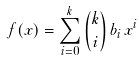Convert formula to latex. <formula><loc_0><loc_0><loc_500><loc_500>f ( x ) = \sum _ { i = 0 } ^ { k } { k \choose i } \, b _ { i } \, x ^ { i }</formula> 